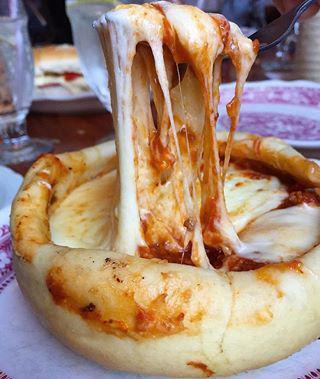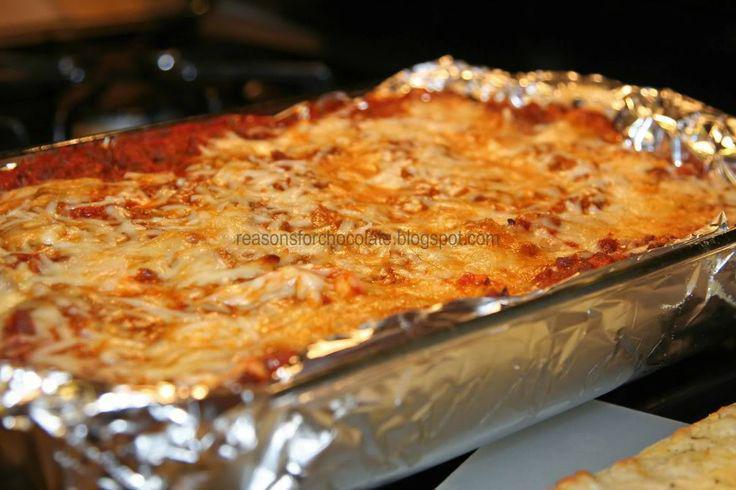The first image is the image on the left, the second image is the image on the right. Considering the images on both sides, is "There is a pizza pot pie in the center of each image." valid? Answer yes or no. No. The first image is the image on the left, the second image is the image on the right. Analyze the images presented: Is the assertion "One image shows a fork above a single-serve round pizza with a rolled crust edge, and cheese is stretching from the fork to the pizza." valid? Answer yes or no. Yes. 